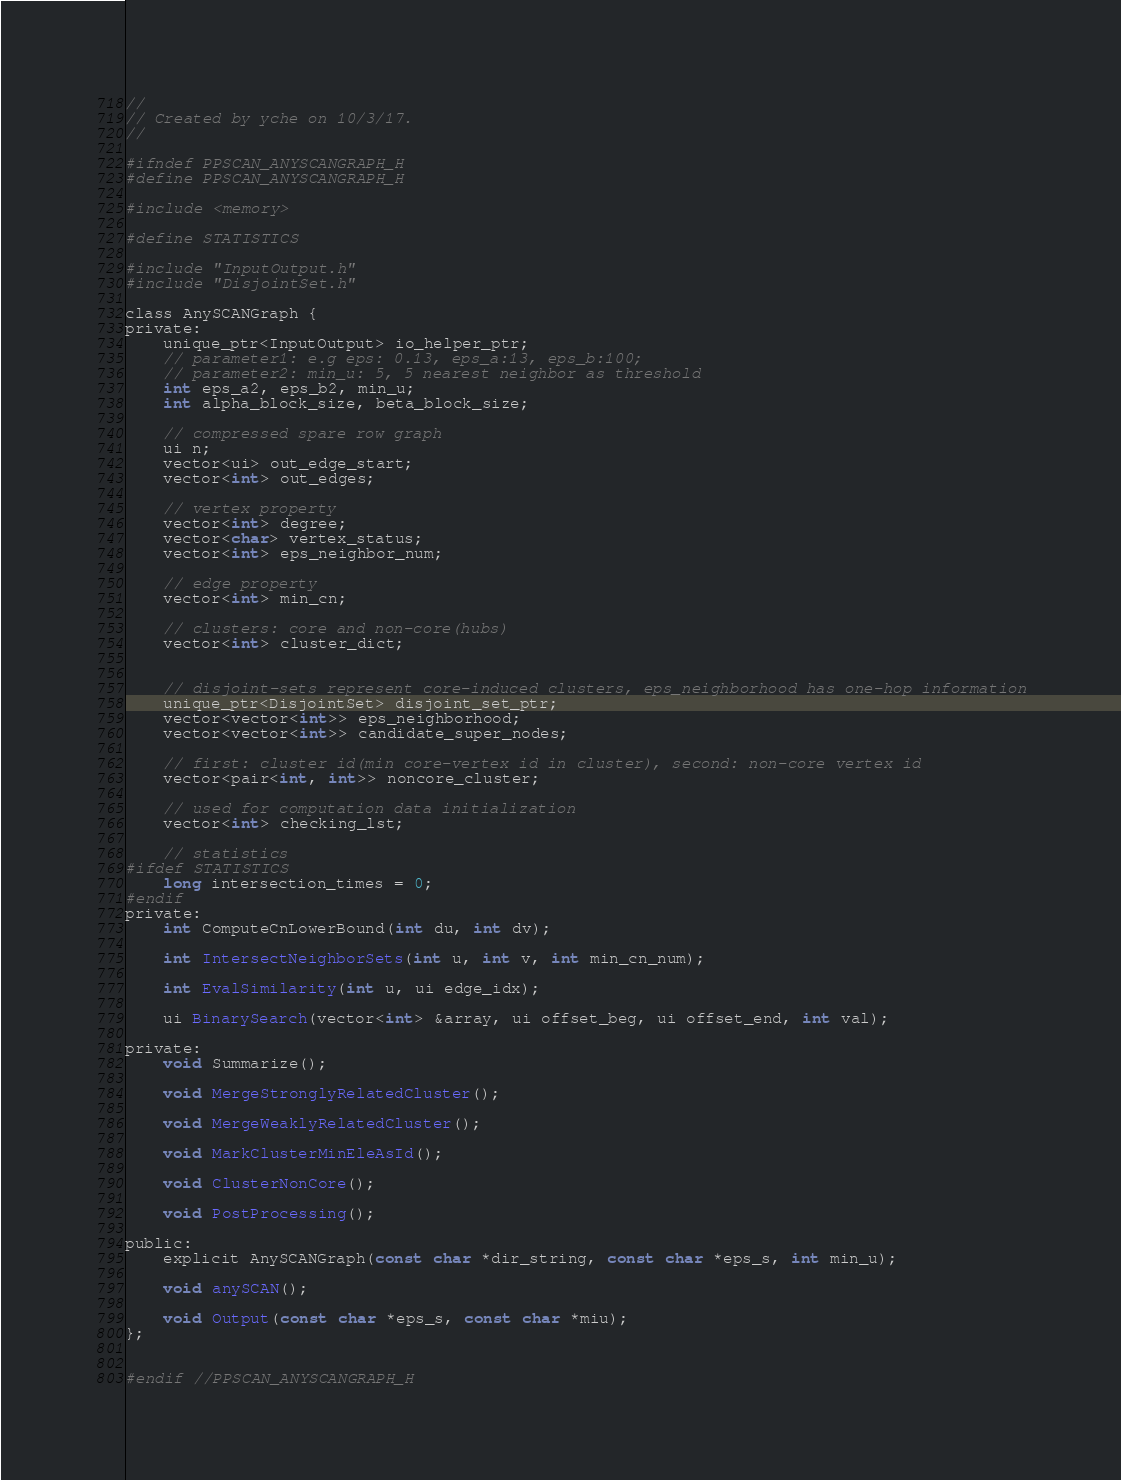<code> <loc_0><loc_0><loc_500><loc_500><_C_>//
// Created by yche on 10/3/17.
//

#ifndef PPSCAN_ANYSCANGRAPH_H
#define PPSCAN_ANYSCANGRAPH_H

#include <memory>

#define STATISTICS

#include "InputOutput.h"
#include "DisjointSet.h"

class AnySCANGraph {
private:
    unique_ptr<InputOutput> io_helper_ptr;
    // parameter1: e.g eps: 0.13, eps_a:13, eps_b:100;
    // parameter2: min_u: 5, 5 nearest neighbor as threshold
    int eps_a2, eps_b2, min_u;
    int alpha_block_size, beta_block_size;

    // compressed spare row graph
    ui n;
    vector<ui> out_edge_start;
    vector<int> out_edges;

    // vertex property
    vector<int> degree;
    vector<char> vertex_status;
    vector<int> eps_neighbor_num;

    // edge property
    vector<int> min_cn;

    // clusters: core and non-core(hubs)
    vector<int> cluster_dict;


    // disjoint-sets represent core-induced clusters, eps_neighborhood has one-hop information
    unique_ptr<DisjointSet> disjoint_set_ptr;
    vector<vector<int>> eps_neighborhood;
    vector<vector<int>> candidate_super_nodes;

    // first: cluster id(min core-vertex id in cluster), second: non-core vertex id
    vector<pair<int, int>> noncore_cluster;

    // used for computation data initialization
    vector<int> checking_lst;

    // statistics
#ifdef STATISTICS
    long intersection_times = 0;
#endif
private:
    int ComputeCnLowerBound(int du, int dv);

    int IntersectNeighborSets(int u, int v, int min_cn_num);

    int EvalSimilarity(int u, ui edge_idx);

    ui BinarySearch(vector<int> &array, ui offset_beg, ui offset_end, int val);

private:
    void Summarize();

    void MergeStronglyRelatedCluster();

    void MergeWeaklyRelatedCluster();

    void MarkClusterMinEleAsId();

    void ClusterNonCore();

    void PostProcessing();

public:
    explicit AnySCANGraph(const char *dir_string, const char *eps_s, int min_u);

    void anySCAN();

    void Output(const char *eps_s, const char *miu);
};


#endif //PPSCAN_ANYSCANGRAPH_H
</code> 